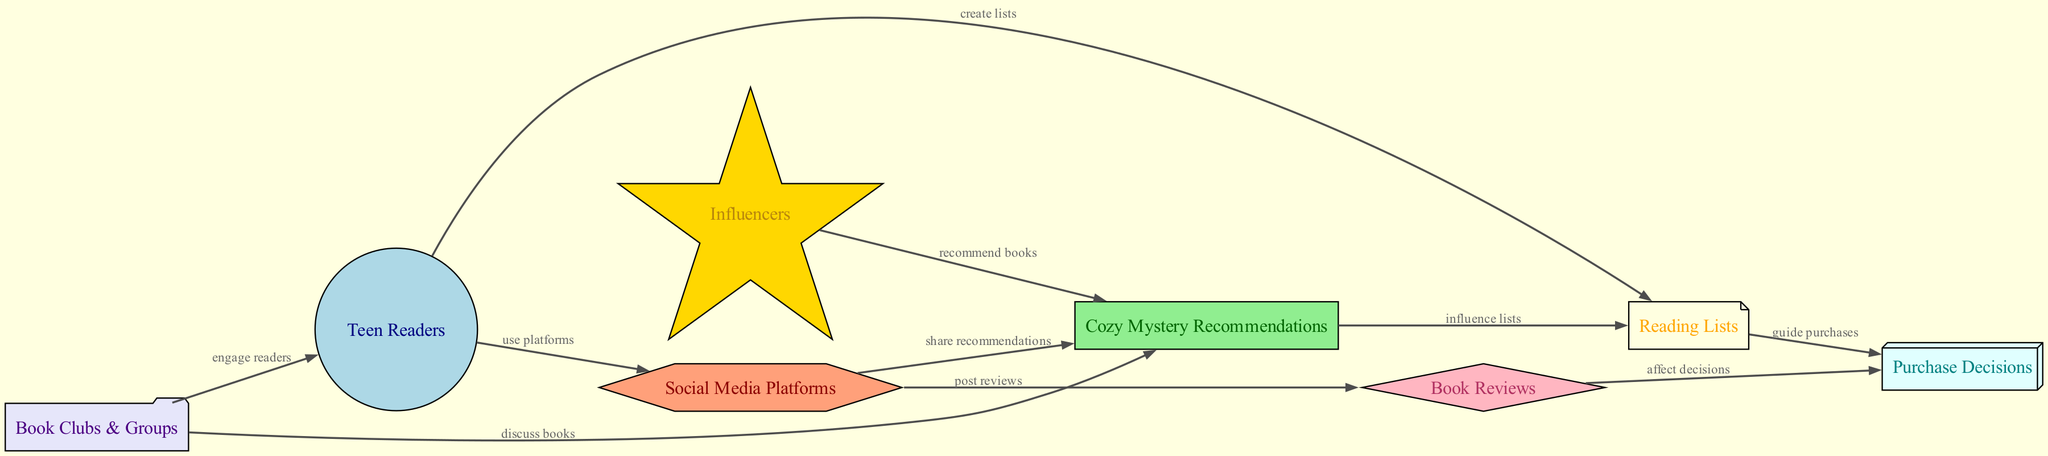What is the total number of nodes in the diagram? The diagram includes the following nodes: Teen Readers, Cozy Mystery Recommendations, Social Media Platforms, Book Reviews, Reading Lists, Purchase Decisions, Influencers, and Book Clubs & Groups. Counting these gives a total of 8 nodes.
Answer: 8 Which node is influenced directly by Book Reviews? Looking at the edges, Book Reviews directly affects Purchase Decisions. There is an edge going from Book Reviews to Purchase Decisions that indicates this influence.
Answer: Purchase Decisions What is the relationship between Social Media Platforms and Cozy Mystery Recommendations? There is an edge directed from Social Media Platforms to Cozy Mystery Recommendations with the label "share recommendations," indicating that Social Media Platforms enable the sharing of these recommendations.
Answer: share recommendations How many edges are in the diagram? The diagram displays relationships (edges) between the nodes. By counting these connections, we find there are 10 edges total connecting various nodes in the diagram.
Answer: 10 What is the role of Influencers in regards to Cozy Mystery Recommendations? The diagram shows an edge from Influencers to Cozy Mystery Recommendations marked as "recommend books." This denotes that influencers play a role in recommending cozy mystery books to their audience.
Answer: recommend books Which node does Teen Readers use that connects to Social Media Platforms? From the diagram, it can be seen that Teen Readers are connected to Social Media Platforms using an edge labeled "use platforms." This indicates that Teen Readers actively engage with social media platforms.
Answer: use platforms Which node guides Purchase Decisions? The Reading Lists node in the diagram is connected to Purchase Decisions with an edge labeled "guide purchases," indicating that the lists help guide what books are purchased.
Answer: guide purchases What do Book Clubs & Groups do concerning Cozy Mystery Recommendations? The diagram indicates that Book Clubs & Groups discuss books, and they are also connected to Cozy Mystery Recommendations with an edge labeled "discuss books," showing their role in conversation around those recommendations.
Answer: discuss books 